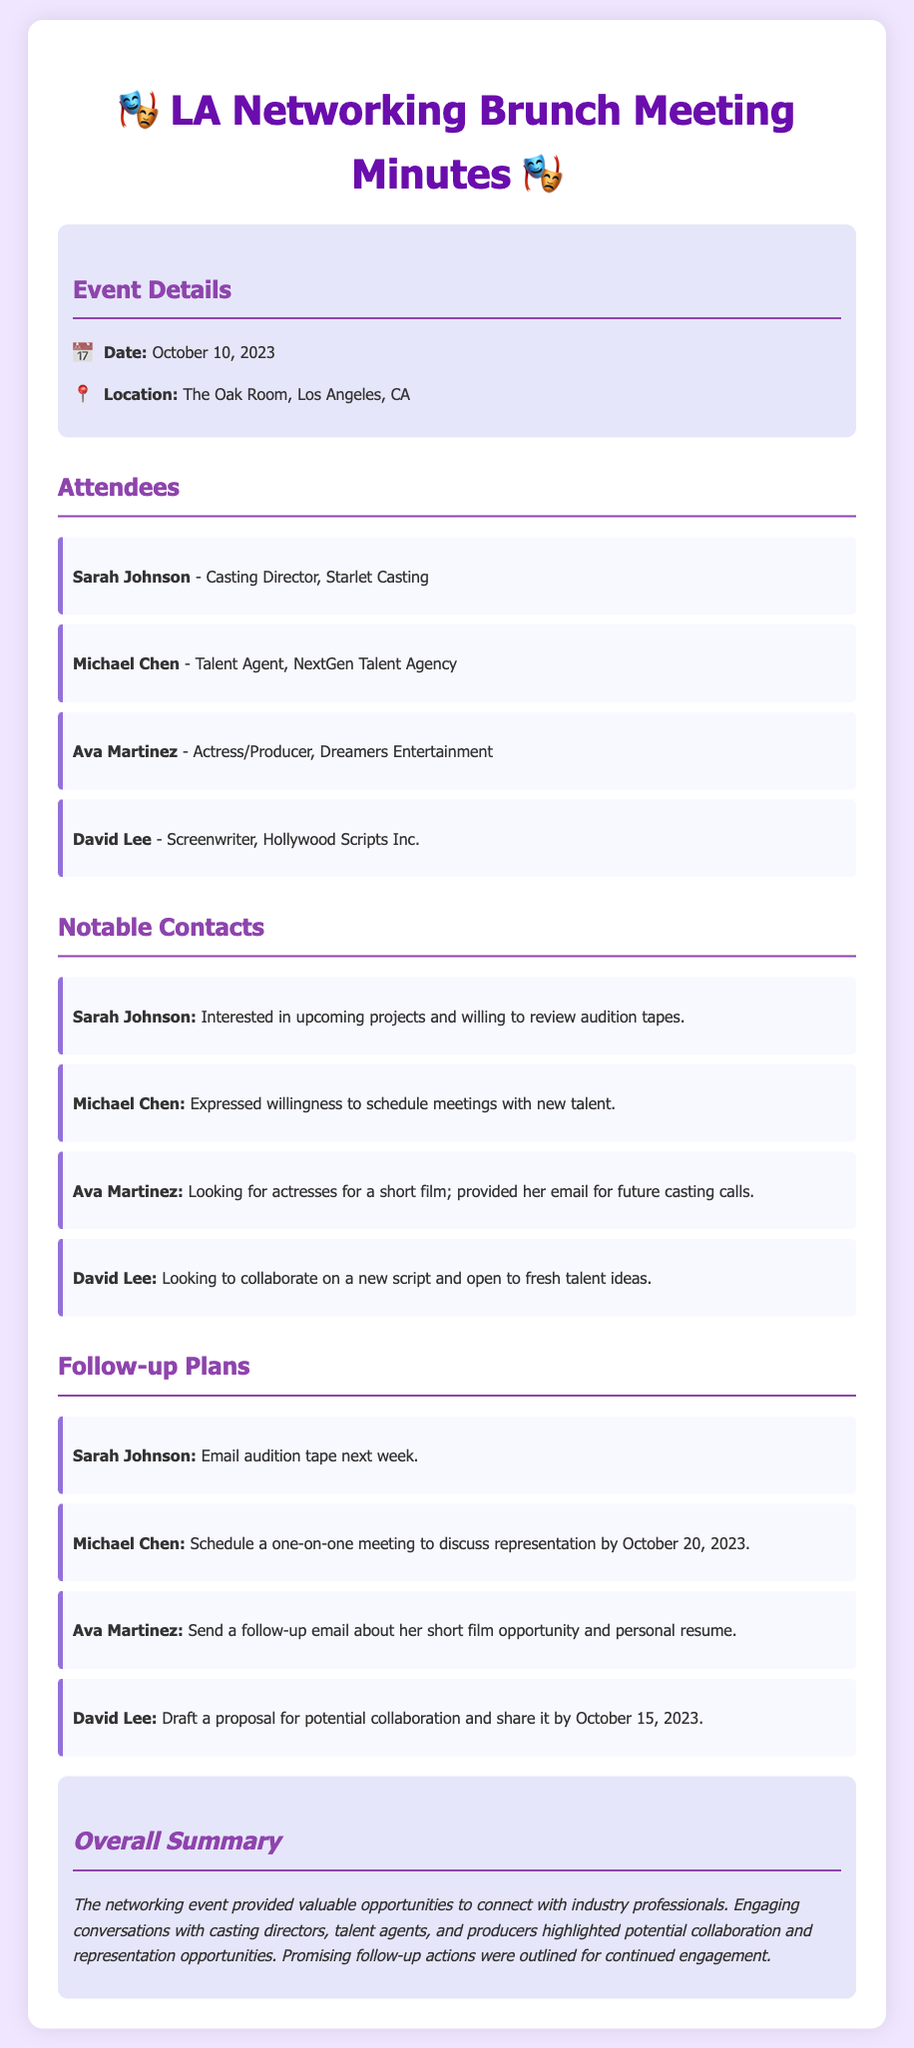What was the date of the event? The date of the event is explicitly mentioned in the document as October 10, 2023.
Answer: October 10, 2023 Where was the networking event held? The location of the event is clearly stated within the event details section of the document as The Oak Room, Los Angeles, CA.
Answer: The Oak Room, Los Angeles, CA Who is the casting director listed among the attendees? The document lists Sarah Johnson as the casting director under the attendees section.
Answer: Sarah Johnson What follow-up action is mentioned for Michael Chen? The follow-up plan for Michael Chen is explicitly stated as scheduling a one-on-one meeting to discuss representation.
Answer: Schedule a one-on-one meeting to discuss representation Which attendee is looking for actresses for a short film? The document mentions Ava Martinez as the attendee interested in finding actresses for her short film.
Answer: Ava Martinez What is a potential collaboration mentioned by David Lee? The document states that David Lee is looking to collaborate on a new script and is open to fresh talent ideas.
Answer: Collaborate on a new script How many notable contacts were made according to the document? The document lists four notable contacts made during the event.
Answer: Four What is the main theme of the overall summary? The overall summary discusses the valuable opportunities to connect with industry professionals and potential collaboration and representation opportunities.
Answer: Valuable opportunities to connect with industry professionals What is the specific deadline for David Lee to share his proposal? The document states that David Lee should share his proposal for potential collaboration by October 15, 2023.
Answer: October 15, 2023 